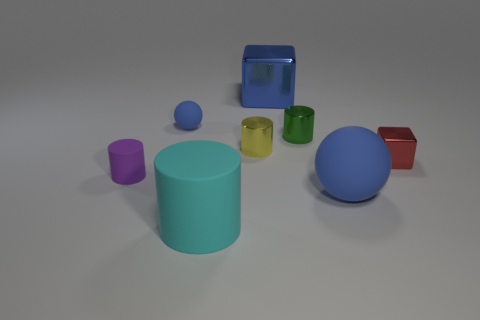There is a big ball that is the same color as the large shiny cube; what is its material?
Ensure brevity in your answer.  Rubber. How many metallic objects are purple cylinders or cylinders?
Your answer should be compact. 2. Is the shape of the big thing to the right of the small green object the same as the tiny matte thing that is in front of the yellow thing?
Provide a short and direct response. No. There is a tiny blue rubber ball; how many matte cylinders are to the right of it?
Keep it short and to the point. 1. Is there a small blue thing made of the same material as the red cube?
Give a very brief answer. No. What is the material of the purple cylinder that is the same size as the red metal object?
Offer a terse response. Rubber. Is the material of the small yellow cylinder the same as the red cube?
Give a very brief answer. Yes. How many things are tiny yellow cylinders or small red blocks?
Your answer should be very brief. 2. There is a big matte object behind the large matte cylinder; what shape is it?
Make the answer very short. Sphere. What color is the other block that is the same material as the blue block?
Give a very brief answer. Red. 